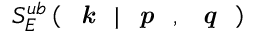<formula> <loc_0><loc_0><loc_500><loc_500>S _ { E } ^ { u b } \left ( k | p , q \right )</formula> 